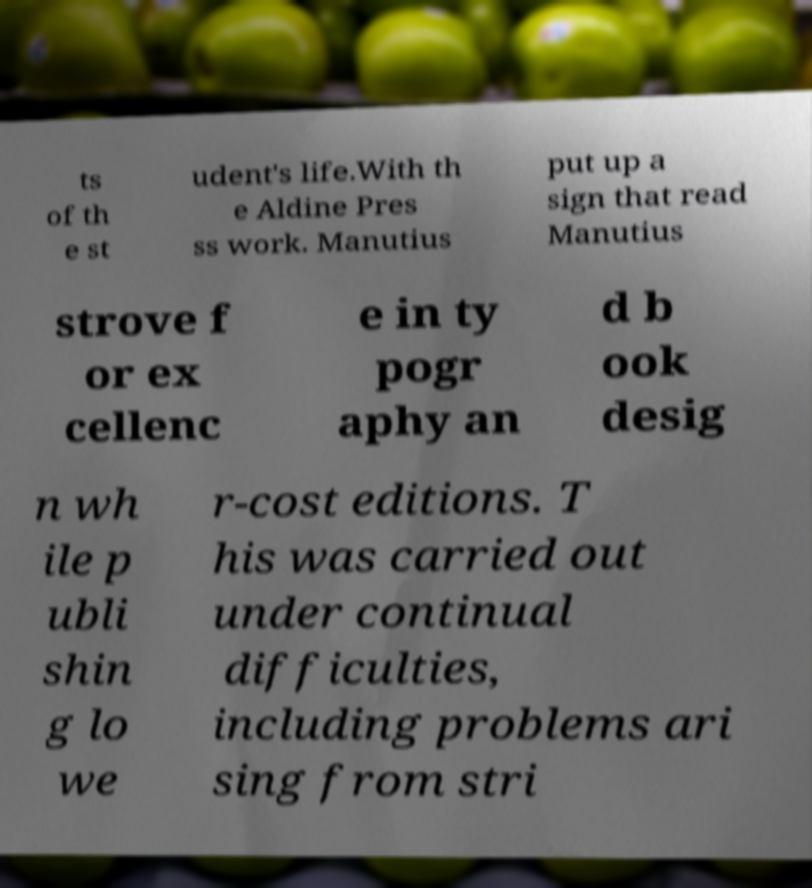Could you assist in decoding the text presented in this image and type it out clearly? ts of th e st udent's life.With th e Aldine Pres ss work. Manutius put up a sign that read Manutius strove f or ex cellenc e in ty pogr aphy an d b ook desig n wh ile p ubli shin g lo we r-cost editions. T his was carried out under continual difficulties, including problems ari sing from stri 